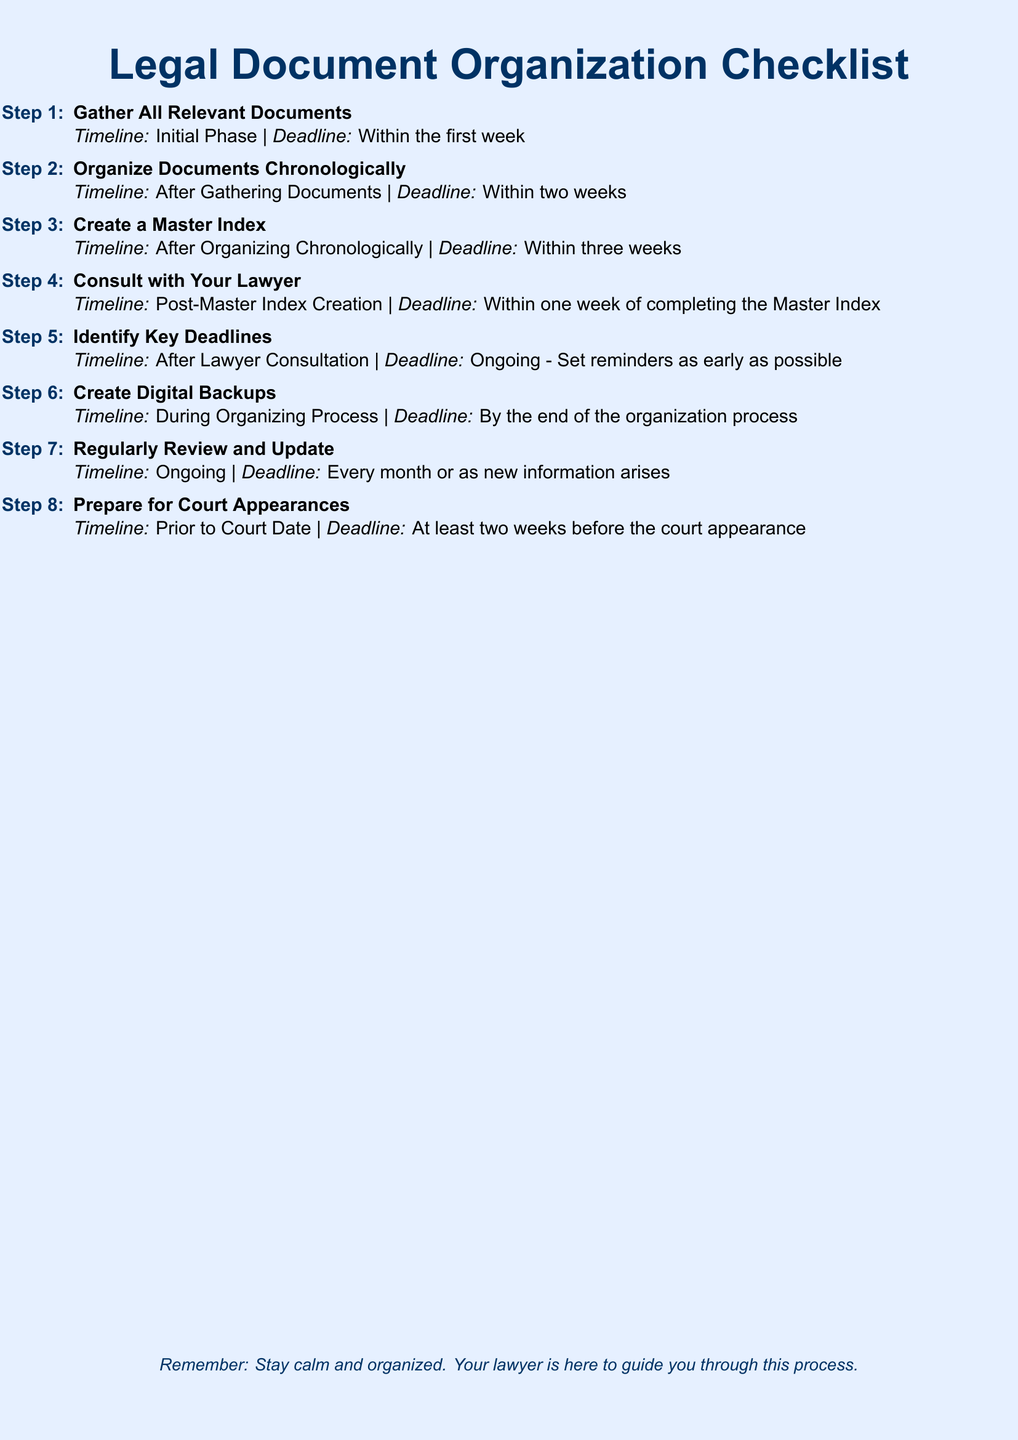What is the title of the document? The title of the document, which is prominently displayed at the top, is "Legal Document Organization Checklist."
Answer: Legal Document Organization Checklist What is the deadline for Step 1? The deadline for Step 1 is clearly stated, which is within the first week.
Answer: Within the first week How many steps are there in the checklist? The document enumerates steps, showing a total of eight steps in the checklist.
Answer: Eight What is the timeline for creating digital backups? The timeline for creating digital backups indicates that this should be done by the end of the organization process.
Answer: By the end of the organization process When should you prepare for court appearances? The document specifies that preparation for court appearances should occur at least two weeks before the court appearance.
Answer: At least two weeks before the court appearance What step involves consulting a lawyer? The document indicates that Step 4 is the one that requires consulting with your lawyer.
Answer: Step 4 What should you do after identifying key deadlines? The checklist indicates that after identifying key deadlines, the task is ongoing, suggesting to set reminders as early as possible.
Answer: Ongoing - Set reminders as early as possible How often should you review and update your documents? The document specifies that reviews and updates should occur every month or as new information arises.
Answer: Every month or as new information arises 